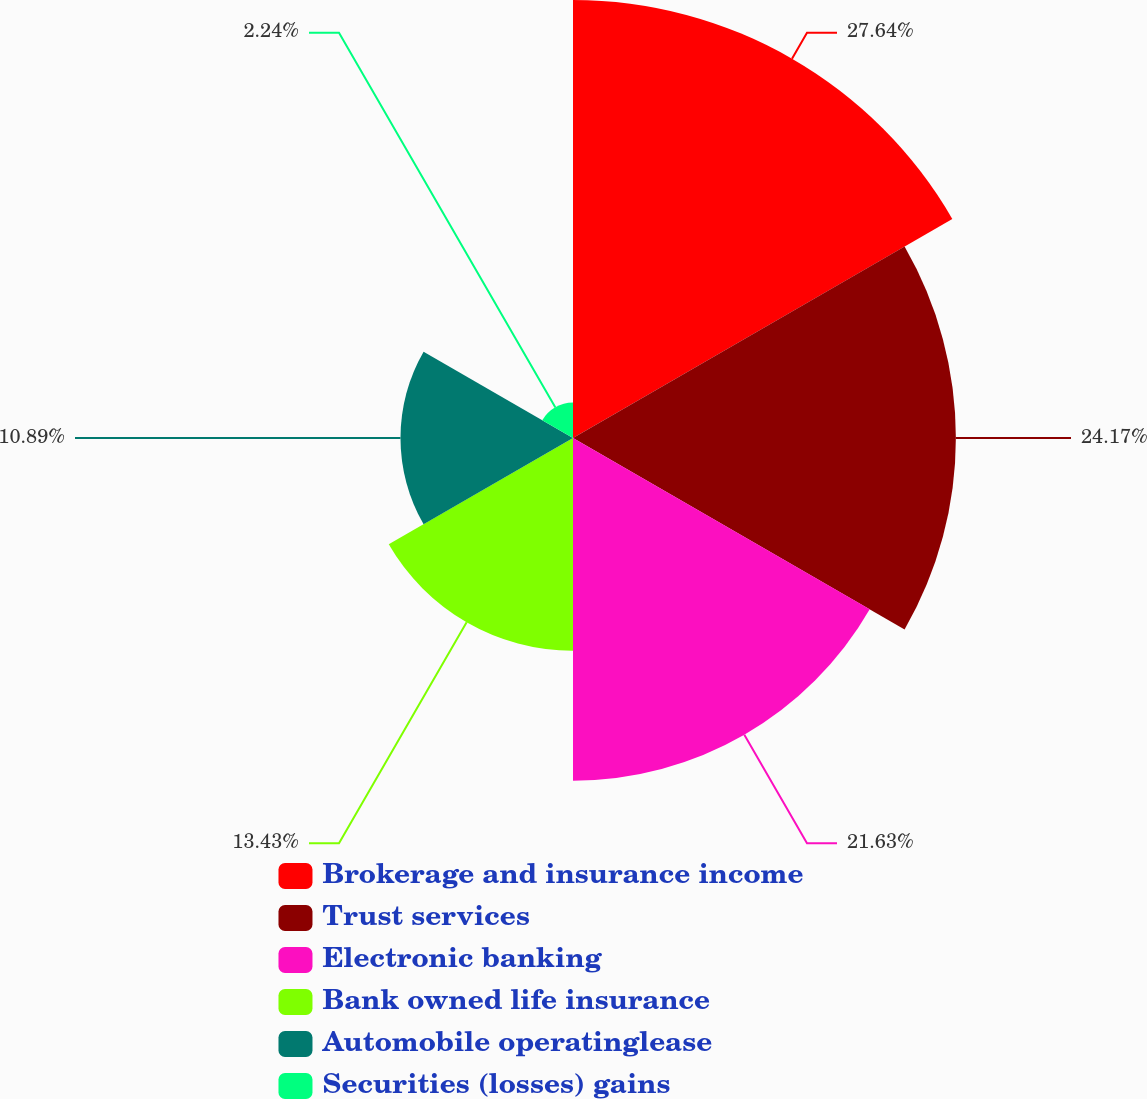Convert chart. <chart><loc_0><loc_0><loc_500><loc_500><pie_chart><fcel>Brokerage and insurance income<fcel>Trust services<fcel>Electronic banking<fcel>Bank owned life insurance<fcel>Automobile operatinglease<fcel>Securities (losses) gains<nl><fcel>27.65%<fcel>24.17%<fcel>21.63%<fcel>13.43%<fcel>10.89%<fcel>2.24%<nl></chart> 